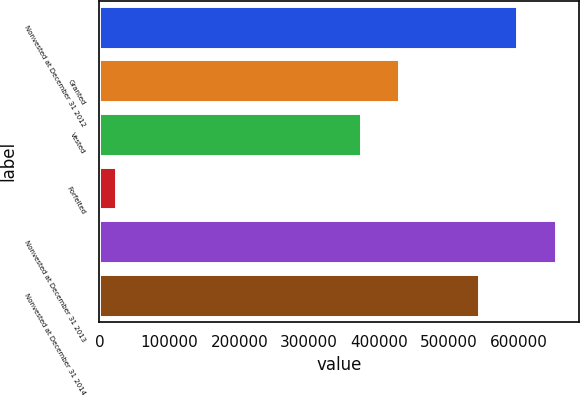Convert chart to OTSL. <chart><loc_0><loc_0><loc_500><loc_500><bar_chart><fcel>Nonvested at December 31 2012<fcel>Granted<fcel>Vested<fcel>Forfeited<fcel>Nonvested at December 31 2013<fcel>Nonvested at December 31 2014<nl><fcel>597575<fcel>428966<fcel>373946<fcel>23649<fcel>652595<fcel>542555<nl></chart> 